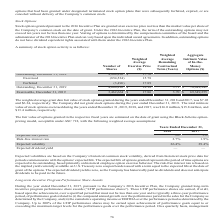According to Aci Worldwide's financial document, What were the number of shares Exercised in 2018? According to the financial document, 854,524. The relevant text states: "Exercised (854,524 ) 15.78..." Also, What was the weighted average grant date fair value of stock options granted during the years ended December 31, 2018? According to the financial document, $7.03. The relevant text states: "ng the years ended December 31, 2018 and 2017, was $7.03 and $6.24, respectively. The Company did not grant stock options during the year ended December 31,..." Also, What was the weighted average grant date fair value of stock options granted during the years ended December 31, 2017? According to the financial document, $6.24. The relevant text states: "rs ended December 31, 2018 and 2017, was $7.03 and $6.24, respectively. The Company did not grant stock options during the year ended December 31, 2019. The..." Also, can you calculate: What is the difference in the Weighted Average Exercise Price between Exercised and Forfeited stock options? Based on the calculation: 17.89-15.78, the result is 2.11. This is based on the information: "Forfeited (3,496 ) 17.89 Exercised (854,524 ) 15.78..." The key data points involved are: 15.78, 17.89. Also, can you calculate: What is the change in the number of shares between outstanding and exercisable stock options as of December 31, 2019? Based on the calculation: 4,006,816-3,462,664, the result is 544152. This is based on the information: "Outstanding, December 31, 2019 4,006,816 $ 18.18 3.71 $ 78,949,941 Exercisable, December 31, 2019 3,462,664 $ 17.86 3.70 $ 69,349,255..." The key data points involved are: 3,462,664, 4,006,816. Also, can you calculate: What is the difference in the Weighted Average Exercise Price between Exercised and Outstanding stock options in 2018? Based on the calculation: $17.76-15.78, the result is 1.98. This is based on the information: "Outstanding, December 31, 2018 4,864,836 $ 17.76 Exercised (854,524 ) 15.78..." The key data points involved are: 15.78, 17.76. 